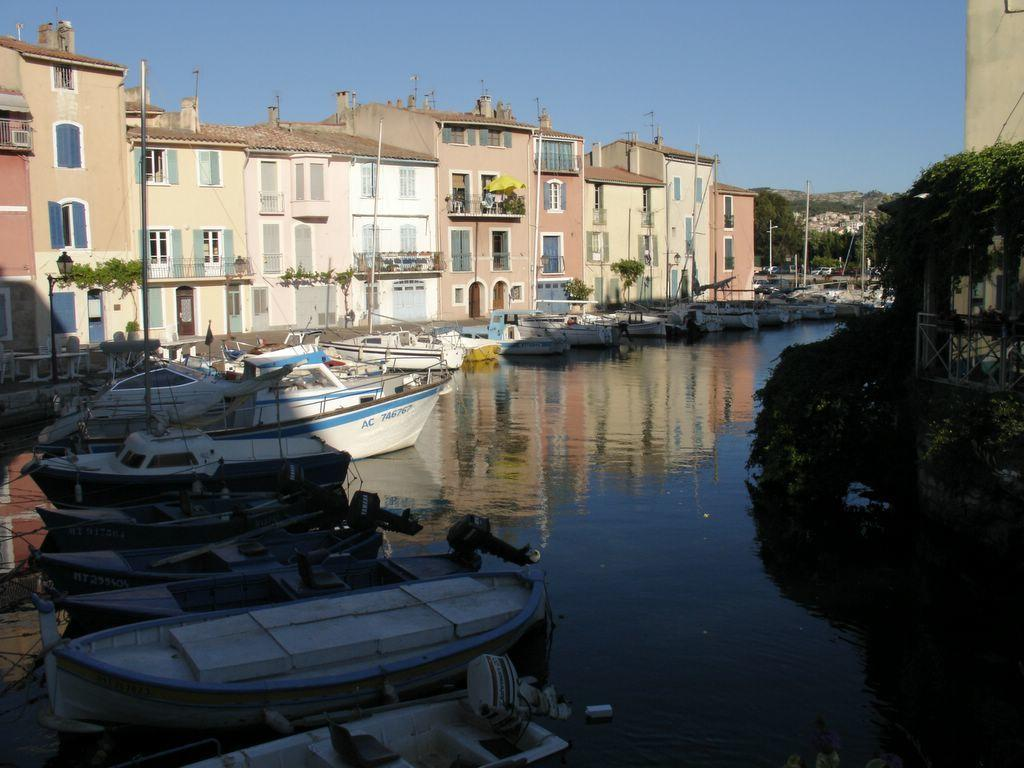What is on the water in the image? There are boats on the water in the image. What can be seen on the right side of the image? There are trees on the right side of the image. What is located on the left side of the image? There are buildings on the left side of the image. What is visible in the sky in the image? Clouds are visible in the sky in the image. Can you tell me what type of lawyer is sitting on the boat in the image? There is no lawyer present in the image; it features boats on the water, trees on the right side, buildings on the left side, and clouds in the sky. What color is the grandfather's hat in the image? There is no grandfather present in the image. 